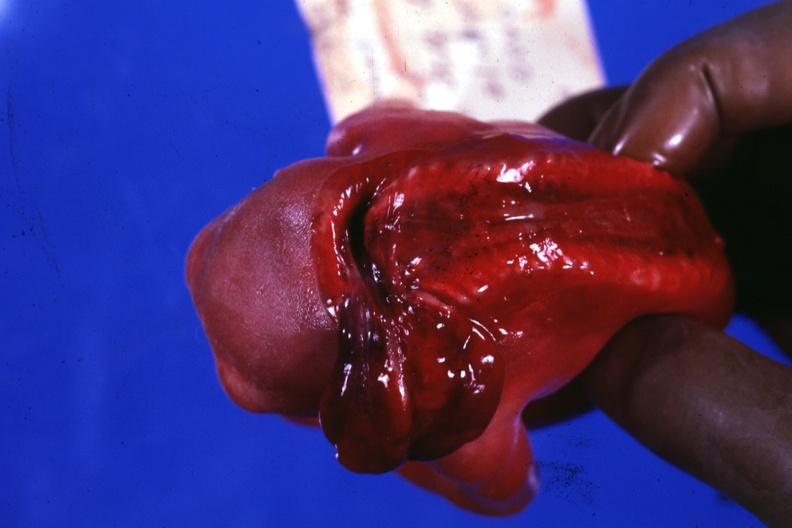what does this image show?
Answer the question using a single word or phrase. Posterior view to show open cord 